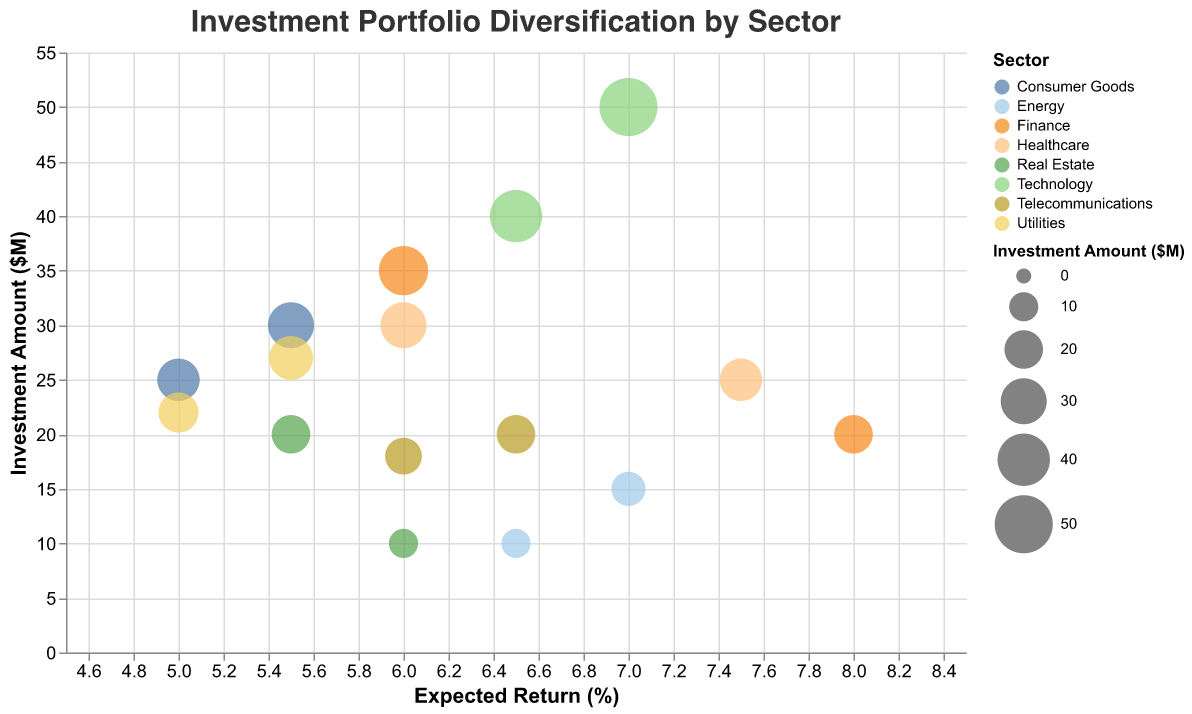How many sectors are represented in the investment portfolio? Count distinct colors representing each sector in the legend.
Answer: 7 Which sector has the highest individual investment amount? Look for the largest bubble on the y-axis (Investment Amount), check which color it corresponds to and refer to the legend.
Answer: Technology What is the expected return for Goldman Sachs? Hover over the bubble for Goldman Sachs in the Finance sector and refer to the tooltip.
Answer: 8% What's the total investment amount in the Healthcare sector? Sum the investment amounts of Johnson & Johnson and Pfizer. $30M (Johnson & Johnson) + $25M (Pfizer) = $55M
Answer: 55M Which sector has the highest average expected return? Average the expected returns of each company within a sector, then compare the averages across sectors.
Answer: Energy How does the risk level correlate with the expected return in the Technology sector? Check the bubbles for Apple and Microsoft in the Technology sector and note their expected returns and risk levels. Both have low risk levels with expected returns of 7% and 6.5%, showing low risk correlates with moderate returns in this sector.
Answer: Low risk has moderate returns What is the range of investment amounts in the Finance sector? Identify the highest and lowest investment amounts for companies in Finance (JPMorgan Chase and Goldman Sachs). $35M (highest) - $20M (lowest)
Answer: 15M Which company in the Telecommunications sector has the higher expected return? Compare the expected returns of companies in the Telecommunications sector. Verizon (6.5%) has a higher return than AT&T (6%).
Answer: Verizon What is the expected return for the largest investment in the Consumer Goods sector? Identify the company with the largest bubble in the Consumer Goods sector and check its expected return. Procter & Gamble has an investment of $30M with an expected return of 5.5%.
Answer: 5.5% Which sector has the most companies with medium risk levels? Count the number of companies with medium risk in each sector. Healthcare, Finance, Real Estate, and Telecommunications each have two companies with medium risk.
Answer: Healthcare, Finance, Real Estate, and Telecommunications 